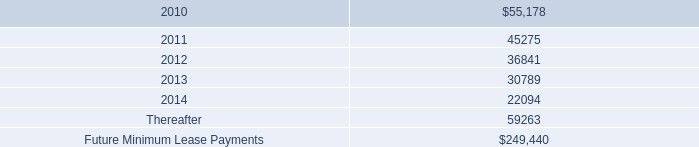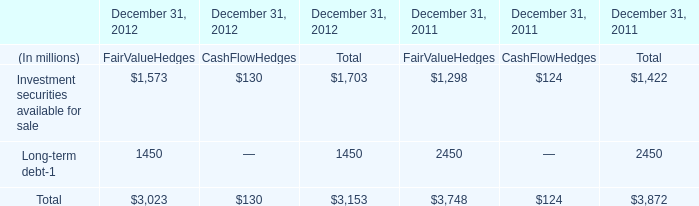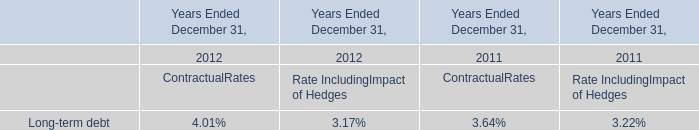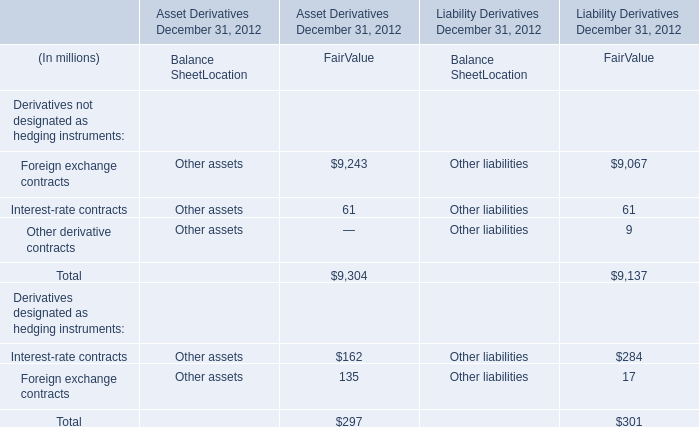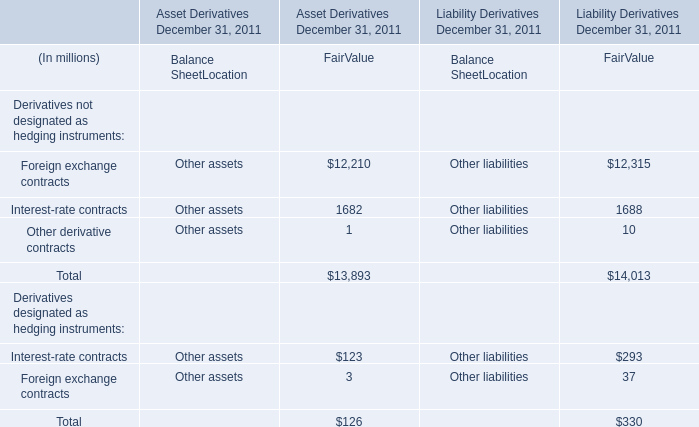What was the total amount of Foreign exchange contracts and Interest-rate contracts in the range of 1 and 13000 in 2011 for FairValue? (in million) 
Computations: (12210 + 1682)
Answer: 13892.0. 